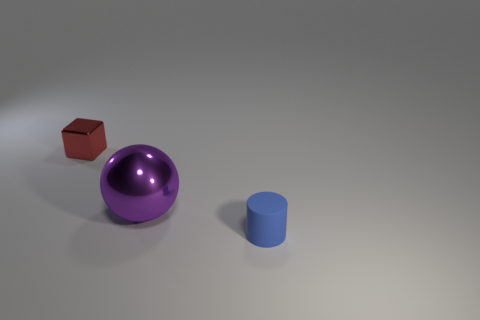Are there any other things that have the same size as the purple metallic thing?
Provide a succinct answer. No. Are there the same number of purple metal spheres that are to the left of the tiny red metal cube and large purple metallic objects left of the purple thing?
Provide a succinct answer. Yes. What color is the thing that is both in front of the small metallic thing and behind the small matte cylinder?
Provide a short and direct response. Purple. Are there more cylinders behind the small red metal thing than large objects in front of the tiny cylinder?
Keep it short and to the point. No. Does the metal object to the right of the red block have the same size as the red shiny thing?
Provide a succinct answer. No. How many big spheres are in front of the metallic thing that is in front of the tiny thing that is behind the tiny matte thing?
Your answer should be compact. 0. What is the size of the object that is both behind the tiny matte thing and on the right side of the red block?
Make the answer very short. Large. How many other things are the same shape as the purple thing?
Your response must be concise. 0. How many things are right of the shiny block?
Your answer should be very brief. 2. Are there fewer purple balls to the left of the red shiny block than large purple balls in front of the purple metal ball?
Your answer should be very brief. No. 